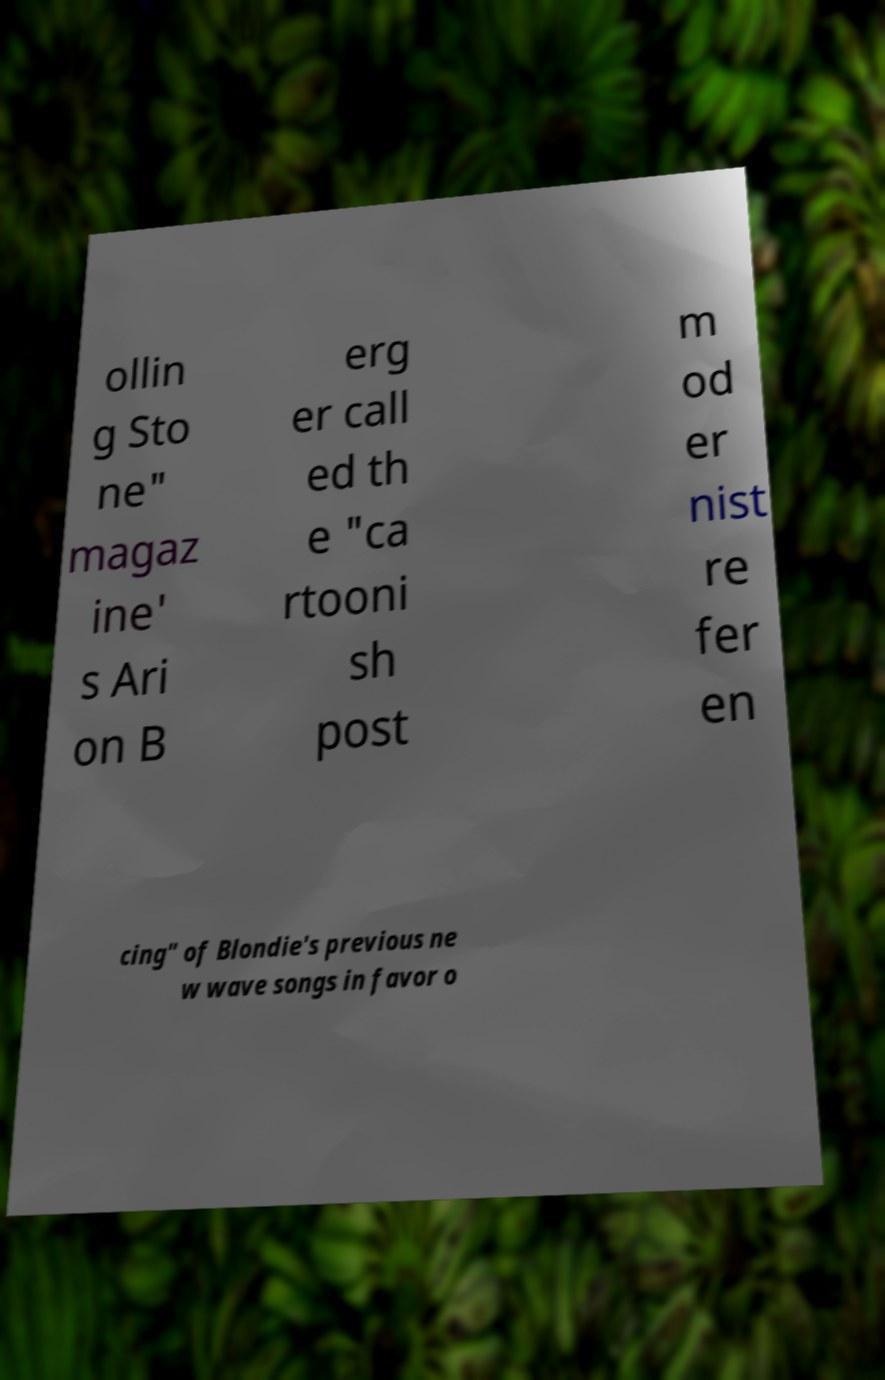For documentation purposes, I need the text within this image transcribed. Could you provide that? ollin g Sto ne" magaz ine' s Ari on B erg er call ed th e "ca rtooni sh post m od er nist re fer en cing" of Blondie's previous ne w wave songs in favor o 